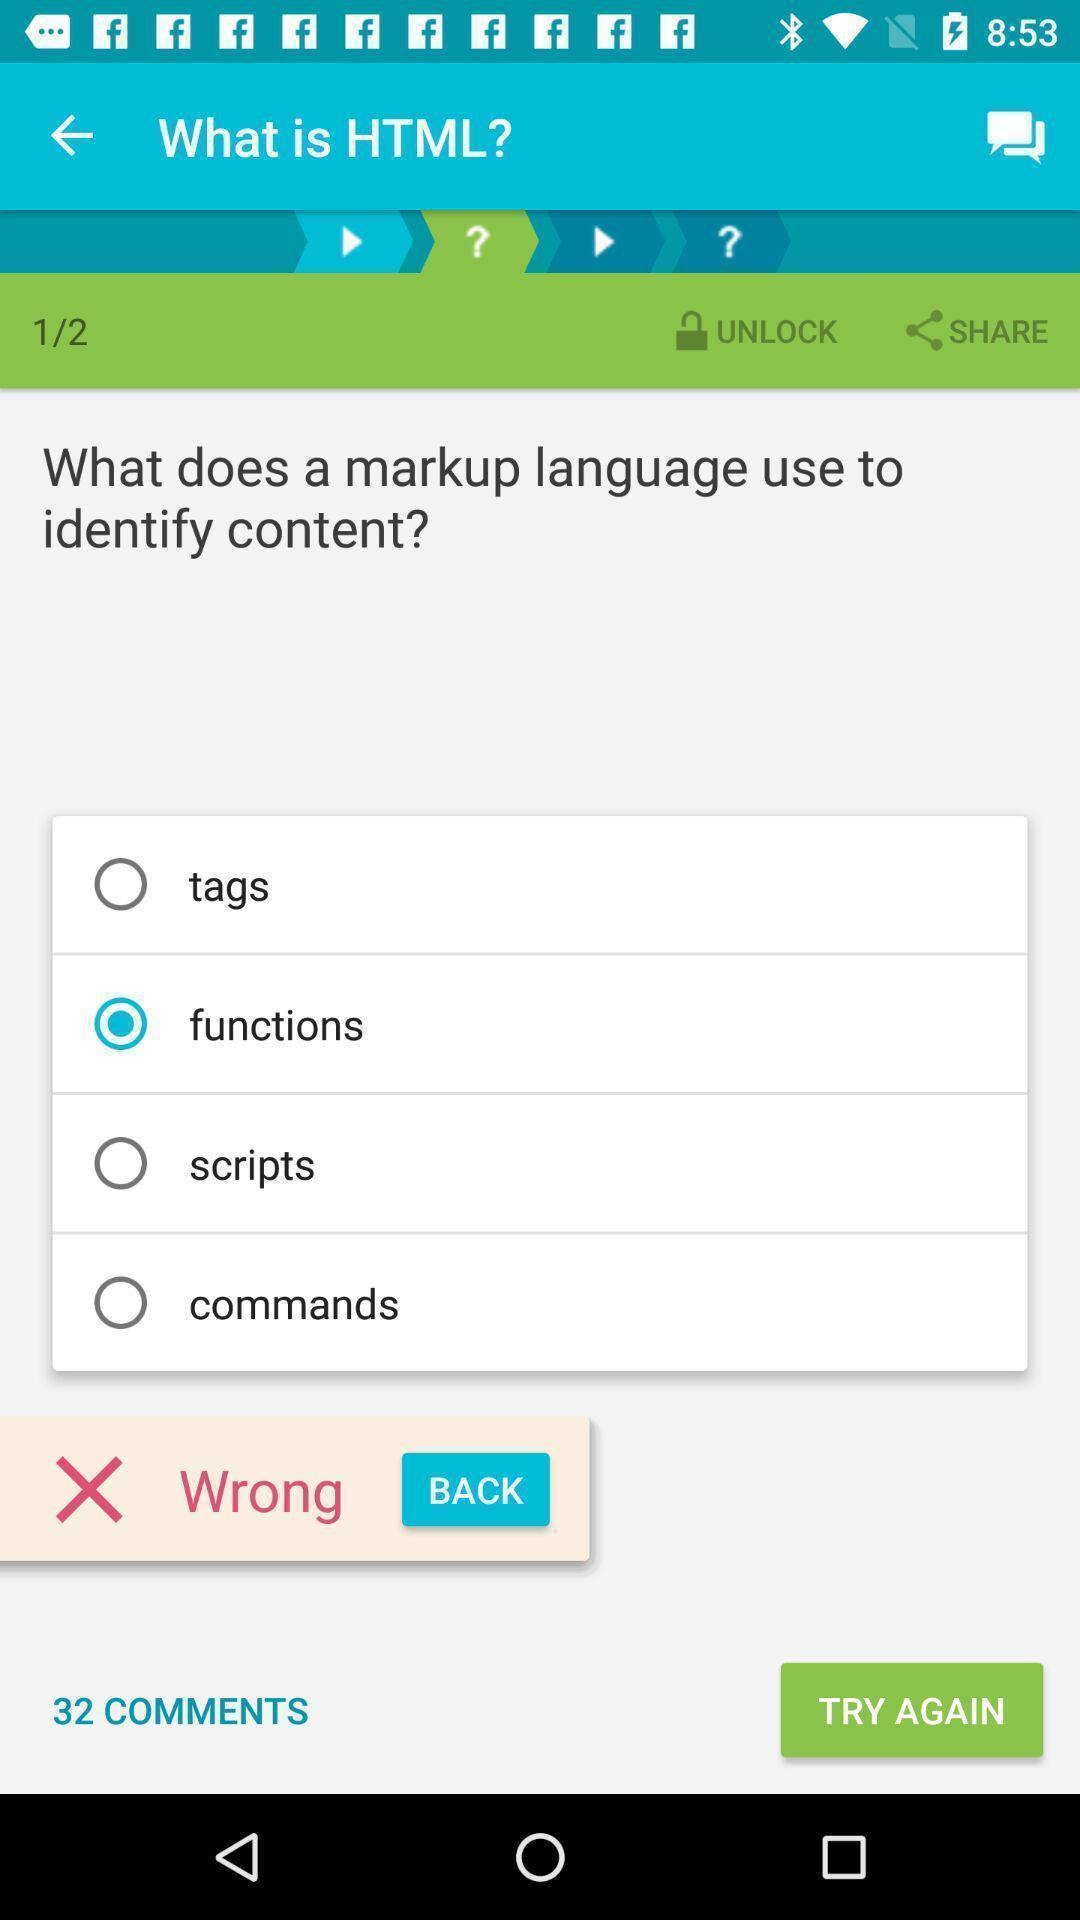Explain the elements present in this screenshot. Page showing information about computer app. 